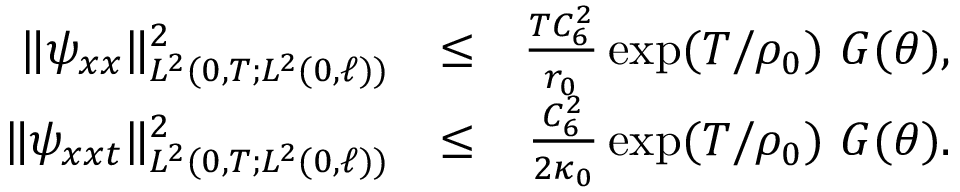<formula> <loc_0><loc_0><loc_500><loc_500>\begin{array} { r l r } { \| \psi _ { x x } \| _ { L ^ { 2 } ( 0 , T ; L ^ { 2 } ( 0 , \ell ) ) } ^ { 2 } } & { \leq } & { \frac { T C _ { 6 } ^ { 2 } } { r _ { 0 } } \exp ( T / \rho _ { 0 } ) \ G ( \theta ) , } \\ { \| \psi _ { x x t } \| _ { L ^ { 2 } ( 0 , T ; L ^ { 2 } ( 0 , \ell ) ) } ^ { 2 } } & { \leq } & { \frac { C _ { 6 } ^ { 2 } } { 2 \kappa _ { 0 } } \exp ( T / \rho _ { 0 } ) \ G ( \theta ) . } \end{array}</formula> 